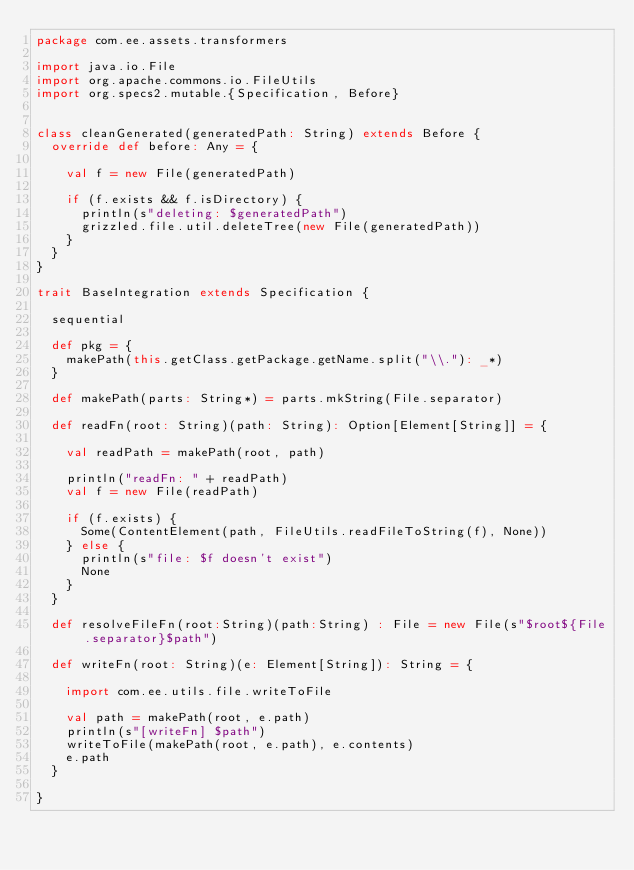<code> <loc_0><loc_0><loc_500><loc_500><_Scala_>package com.ee.assets.transformers

import java.io.File
import org.apache.commons.io.FileUtils
import org.specs2.mutable.{Specification, Before}


class cleanGenerated(generatedPath: String) extends Before {
  override def before: Any = {

    val f = new File(generatedPath)

    if (f.exists && f.isDirectory) {
      println(s"deleting: $generatedPath")
      grizzled.file.util.deleteTree(new File(generatedPath))
    }
  }
}

trait BaseIntegration extends Specification {

  sequential

  def pkg = {
    makePath(this.getClass.getPackage.getName.split("\\."): _*)
  }

  def makePath(parts: String*) = parts.mkString(File.separator)

  def readFn(root: String)(path: String): Option[Element[String]] = {

    val readPath = makePath(root, path)

    println("readFn: " + readPath)
    val f = new File(readPath)

    if (f.exists) {
      Some(ContentElement(path, FileUtils.readFileToString(f), None))
    } else {
      println(s"file: $f doesn't exist")
      None
    }
  }

  def resolveFileFn(root:String)(path:String) : File = new File(s"$root${File.separator}$path")

  def writeFn(root: String)(e: Element[String]): String = {

    import com.ee.utils.file.writeToFile

    val path = makePath(root, e.path)
    println(s"[writeFn] $path")
    writeToFile(makePath(root, e.path), e.contents)
    e.path
  }

}
</code> 